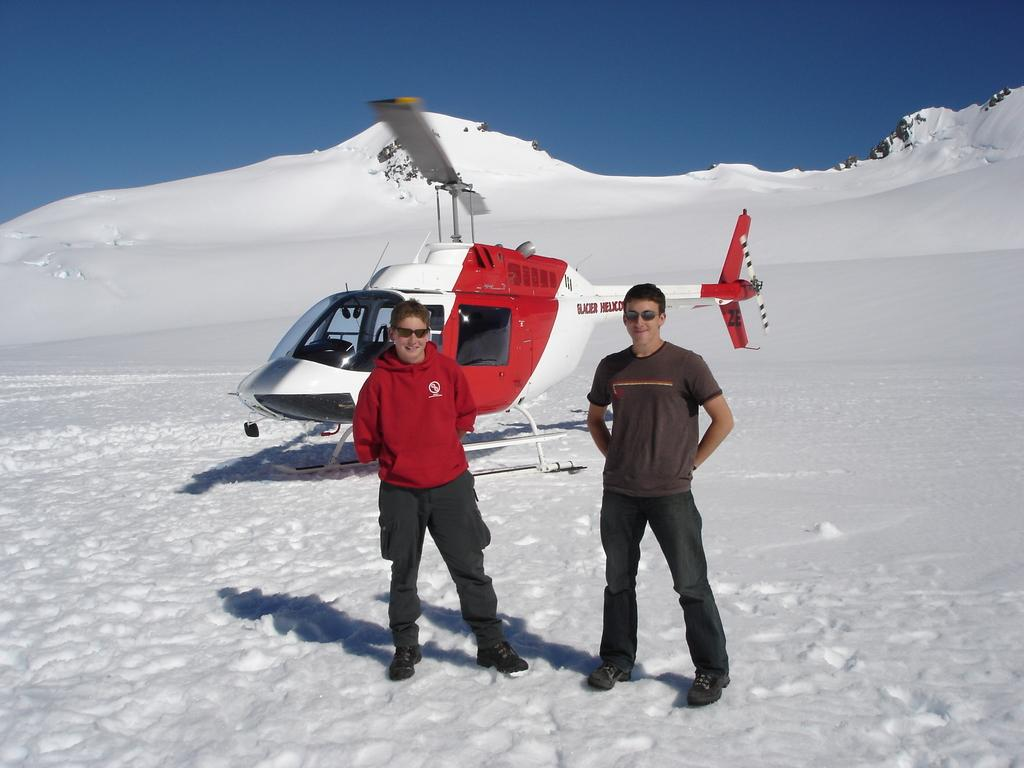How many people are in the image? There are two persons standing at the bottom of the image. What is located in the middle of the image? There is a helicopter on the snow in the middle of the image. What type of terrain is visible in the image? There is a hill at the back side of the image. What is visible at the top of the image? The sky is visible at the top of the image. What time is displayed on the calculator in the image? There is no calculator present in the image. What type of voice can be heard coming from the helicopter in the image? There is no voice or sound coming from the helicopter in the image, as it is a still image. 